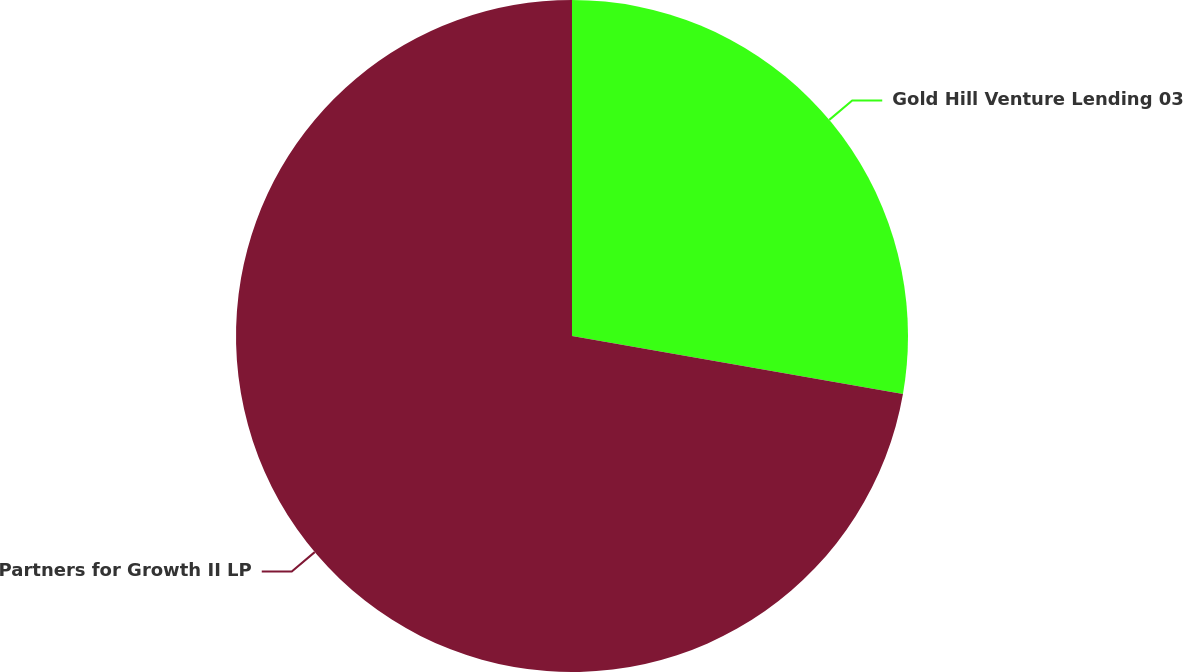Convert chart. <chart><loc_0><loc_0><loc_500><loc_500><pie_chart><fcel>Gold Hill Venture Lending 03<fcel>Partners for Growth II LP<nl><fcel>27.76%<fcel>72.24%<nl></chart> 